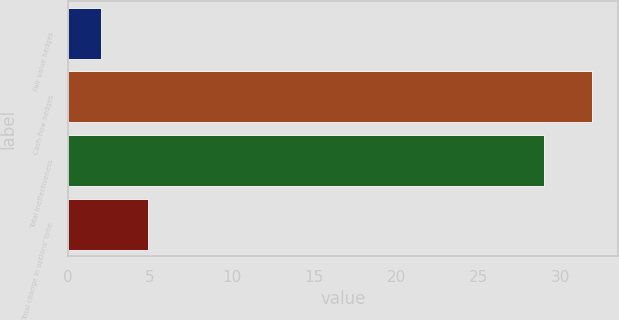Convert chart. <chart><loc_0><loc_0><loc_500><loc_500><bar_chart><fcel>Fair value hedges<fcel>Cash flow hedges<fcel>Total ineffectiveness<fcel>Total change in options' time<nl><fcel>2<fcel>31.9<fcel>29<fcel>4.9<nl></chart> 